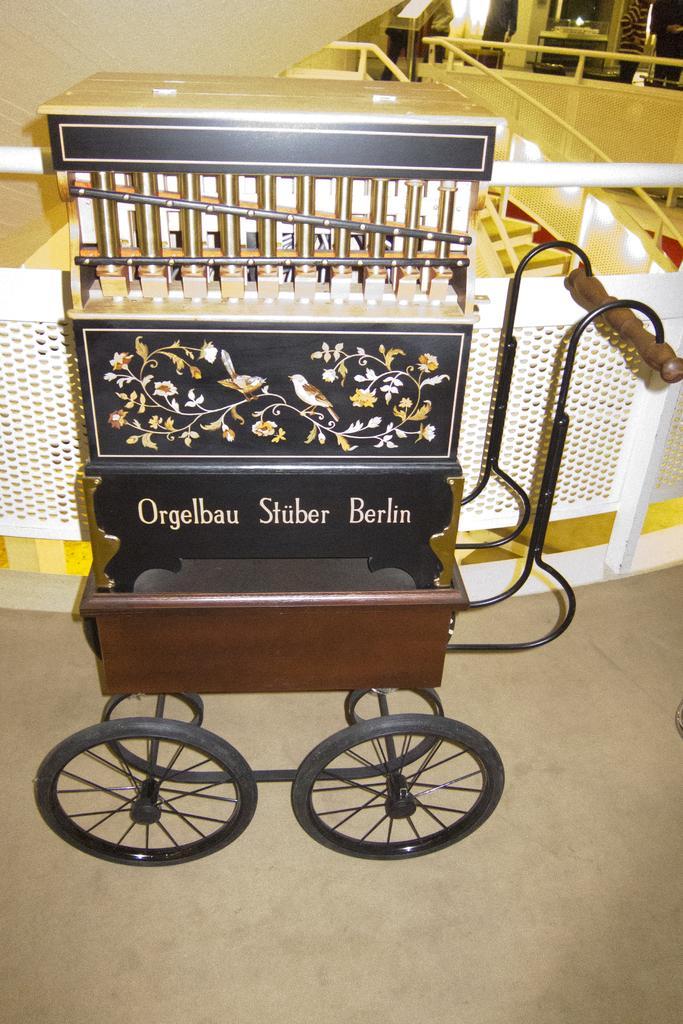Can you describe this image briefly? In the center of the image we can see a musical instrument. In the background there are railings and tables. At the bottom there is a floor. 